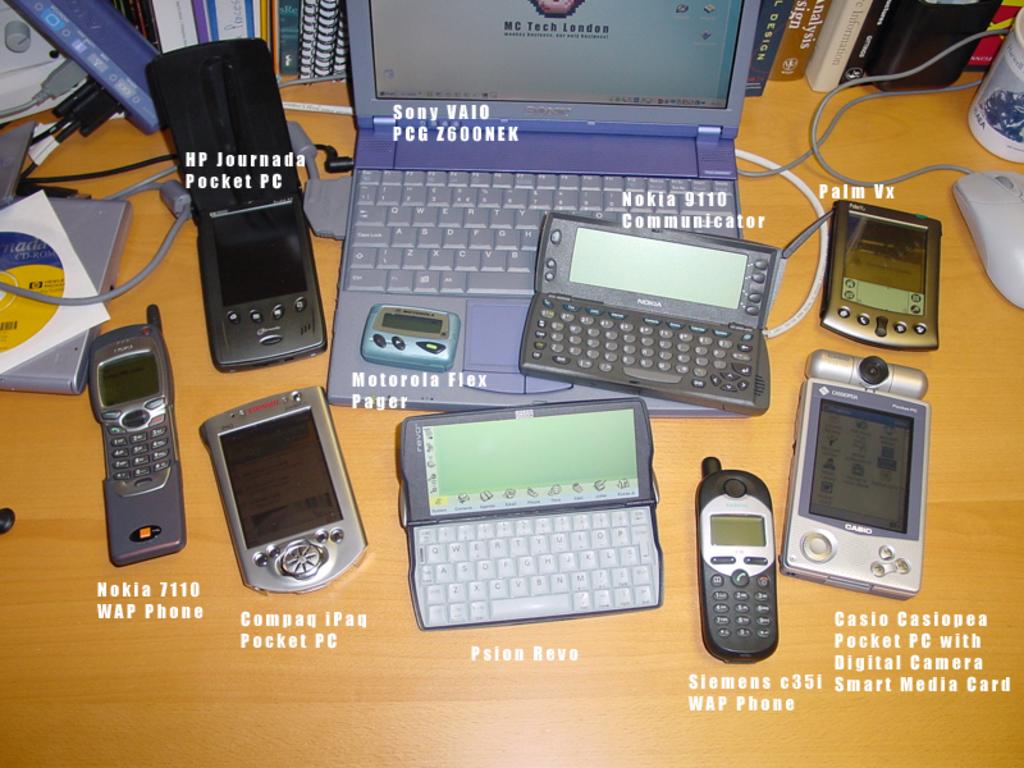Who makes the leftmost device?
Provide a short and direct response. Nokia. What brand is the laptop?
Offer a terse response. Sony. 